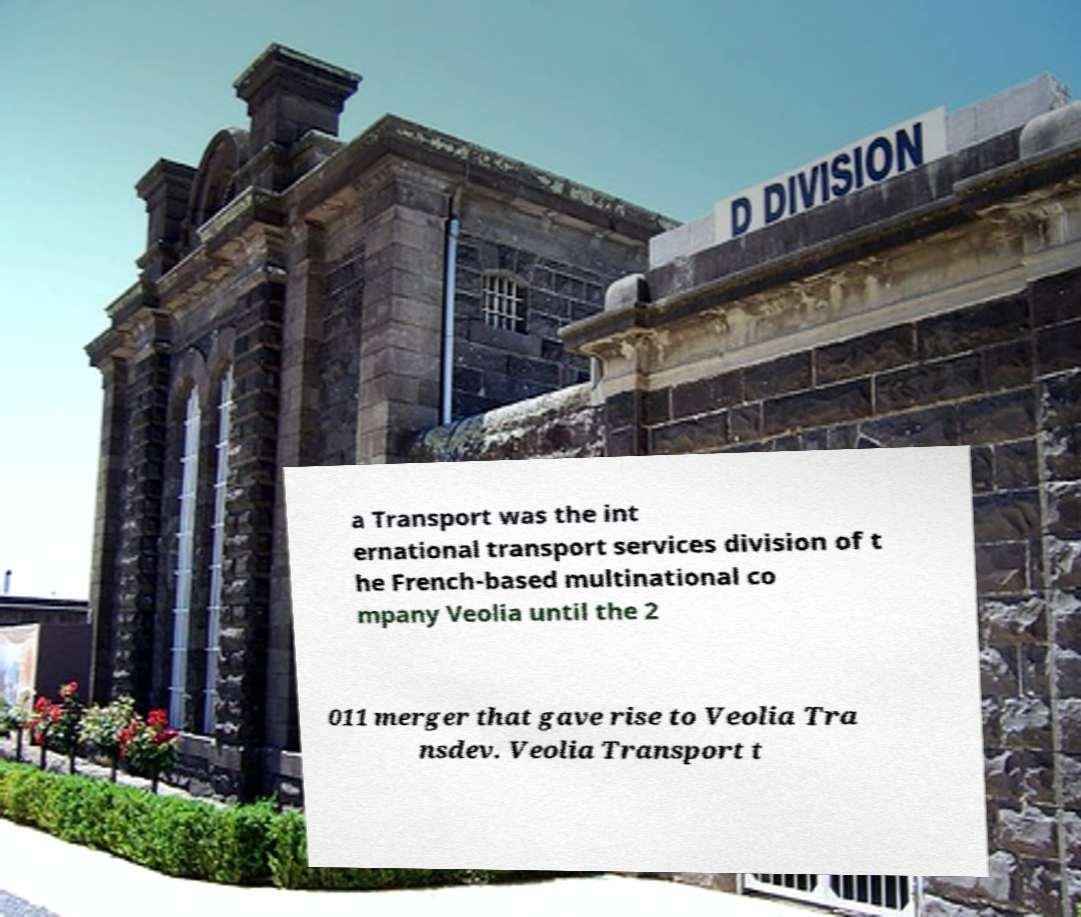Please identify and transcribe the text found in this image. a Transport was the int ernational transport services division of t he French-based multinational co mpany Veolia until the 2 011 merger that gave rise to Veolia Tra nsdev. Veolia Transport t 